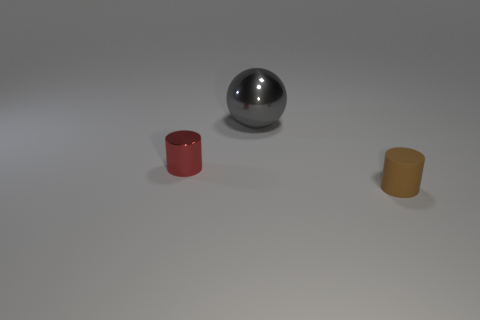Add 1 big brown cubes. How many objects exist? 4 Subtract all spheres. How many objects are left? 2 Add 2 big brown metal spheres. How many big brown metal spheres exist? 2 Subtract 0 red cubes. How many objects are left? 3 Subtract all big blue matte balls. Subtract all large objects. How many objects are left? 2 Add 2 brown matte cylinders. How many brown matte cylinders are left? 3 